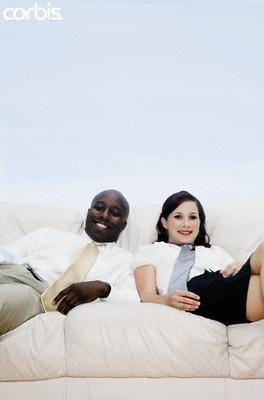What room are they in?
Be succinct. Living room. What does the man have around his neck?
Keep it brief. Tie. What are the man and lady doing?
Be succinct. Sitting. How many black people?
Answer briefly. 1. What color is the man's tie?
Short answer required. Gold. What are the man and lady's heads laying on?
Answer briefly. Couch. 